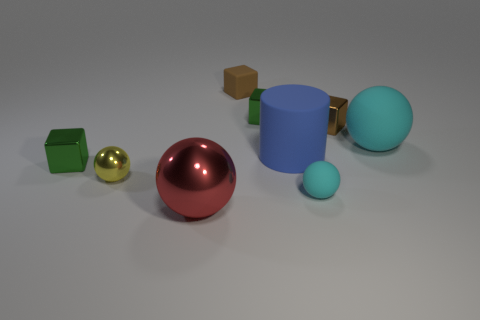Add 1 big metal things. How many objects exist? 10 Subtract all spheres. How many objects are left? 5 Subtract 1 red balls. How many objects are left? 8 Subtract all tiny metallic blocks. Subtract all small metal spheres. How many objects are left? 5 Add 5 tiny brown rubber blocks. How many tiny brown rubber blocks are left? 6 Add 2 brown cubes. How many brown cubes exist? 4 